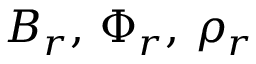Convert formula to latex. <formula><loc_0><loc_0><loc_500><loc_500>B _ { r } , \, \Phi _ { r } , \, \rho _ { r }</formula> 